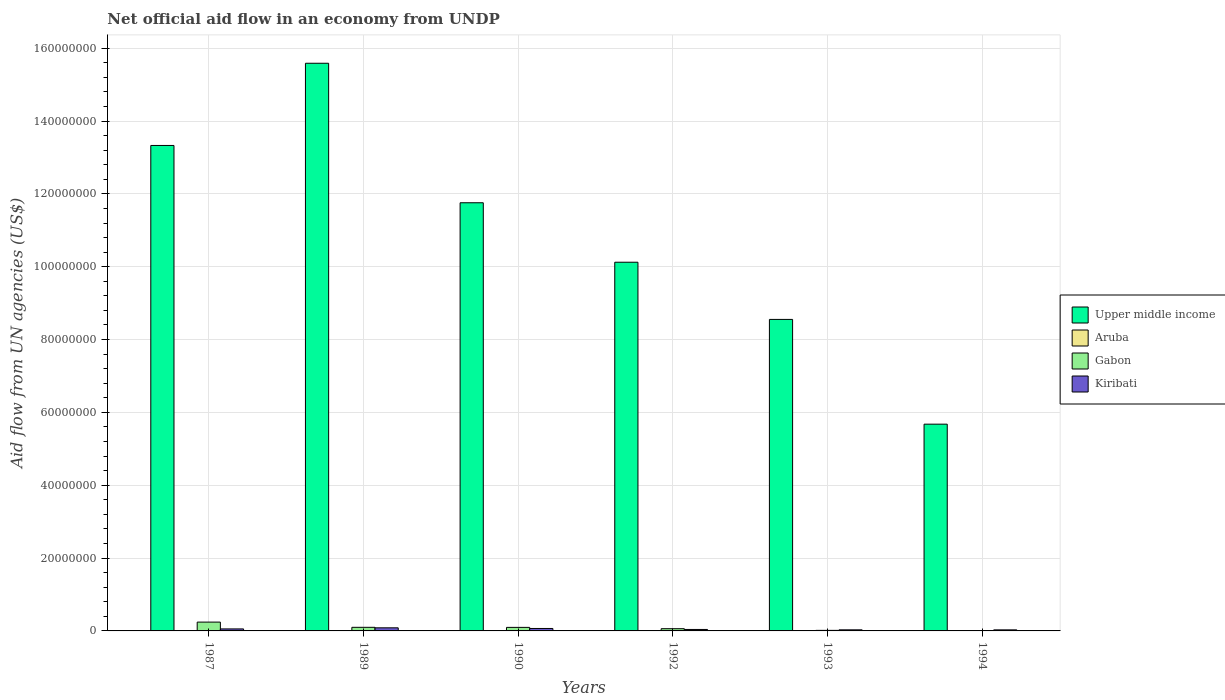How many different coloured bars are there?
Your response must be concise. 4. Are the number of bars per tick equal to the number of legend labels?
Offer a very short reply. No. Are the number of bars on each tick of the X-axis equal?
Give a very brief answer. No. How many bars are there on the 6th tick from the left?
Provide a short and direct response. 3. How many bars are there on the 3rd tick from the right?
Provide a succinct answer. 3. In how many cases, is the number of bars for a given year not equal to the number of legend labels?
Give a very brief answer. 2. Across all years, what is the maximum net official aid flow in Upper middle income?
Make the answer very short. 1.56e+08. In which year was the net official aid flow in Gabon maximum?
Ensure brevity in your answer.  1987. What is the difference between the net official aid flow in Upper middle income in 1989 and that in 1994?
Ensure brevity in your answer.  9.91e+07. What is the difference between the net official aid flow in Kiribati in 1987 and the net official aid flow in Gabon in 1989?
Offer a terse response. -4.40e+05. What is the average net official aid flow in Kiribati per year?
Your response must be concise. 5.10e+05. In the year 1992, what is the difference between the net official aid flow in Kiribati and net official aid flow in Upper middle income?
Provide a succinct answer. -1.01e+08. What is the ratio of the net official aid flow in Kiribati in 1987 to that in 1989?
Offer a terse response. 0.65. Is the net official aid flow in Upper middle income in 1990 less than that in 1993?
Make the answer very short. No. What is the difference between the highest and the second highest net official aid flow in Gabon?
Ensure brevity in your answer.  1.43e+06. What is the difference between the highest and the lowest net official aid flow in Gabon?
Make the answer very short. 2.40e+06. In how many years, is the net official aid flow in Aruba greater than the average net official aid flow in Aruba taken over all years?
Give a very brief answer. 3. Is it the case that in every year, the sum of the net official aid flow in Gabon and net official aid flow in Kiribati is greater than the net official aid flow in Aruba?
Your answer should be compact. Yes. Are all the bars in the graph horizontal?
Your answer should be very brief. No. What is the difference between two consecutive major ticks on the Y-axis?
Your answer should be compact. 2.00e+07. Are the values on the major ticks of Y-axis written in scientific E-notation?
Ensure brevity in your answer.  No. Does the graph contain any zero values?
Provide a succinct answer. Yes. Where does the legend appear in the graph?
Keep it short and to the point. Center right. How many legend labels are there?
Ensure brevity in your answer.  4. How are the legend labels stacked?
Offer a terse response. Vertical. What is the title of the graph?
Make the answer very short. Net official aid flow in an economy from UNDP. What is the label or title of the X-axis?
Give a very brief answer. Years. What is the label or title of the Y-axis?
Ensure brevity in your answer.  Aid flow from UN agencies (US$). What is the Aid flow from UN agencies (US$) of Upper middle income in 1987?
Give a very brief answer. 1.33e+08. What is the Aid flow from UN agencies (US$) in Aruba in 1987?
Make the answer very short. 8.00e+04. What is the Aid flow from UN agencies (US$) in Gabon in 1987?
Provide a succinct answer. 2.42e+06. What is the Aid flow from UN agencies (US$) of Upper middle income in 1989?
Provide a succinct answer. 1.56e+08. What is the Aid flow from UN agencies (US$) in Aruba in 1989?
Keep it short and to the point. 8.00e+04. What is the Aid flow from UN agencies (US$) of Gabon in 1989?
Keep it short and to the point. 9.90e+05. What is the Aid flow from UN agencies (US$) in Kiribati in 1989?
Your response must be concise. 8.50e+05. What is the Aid flow from UN agencies (US$) of Upper middle income in 1990?
Ensure brevity in your answer.  1.18e+08. What is the Aid flow from UN agencies (US$) of Gabon in 1990?
Offer a terse response. 9.70e+05. What is the Aid flow from UN agencies (US$) of Kiribati in 1990?
Keep it short and to the point. 6.70e+05. What is the Aid flow from UN agencies (US$) in Upper middle income in 1992?
Your response must be concise. 1.01e+08. What is the Aid flow from UN agencies (US$) in Gabon in 1992?
Make the answer very short. 6.10e+05. What is the Aid flow from UN agencies (US$) of Upper middle income in 1993?
Provide a succinct answer. 8.55e+07. What is the Aid flow from UN agencies (US$) in Aruba in 1993?
Your answer should be compact. 1.10e+05. What is the Aid flow from UN agencies (US$) in Upper middle income in 1994?
Give a very brief answer. 5.68e+07. What is the Aid flow from UN agencies (US$) of Aruba in 1994?
Offer a terse response. 0. Across all years, what is the maximum Aid flow from UN agencies (US$) in Upper middle income?
Your answer should be compact. 1.56e+08. Across all years, what is the maximum Aid flow from UN agencies (US$) of Gabon?
Ensure brevity in your answer.  2.42e+06. Across all years, what is the maximum Aid flow from UN agencies (US$) in Kiribati?
Your answer should be very brief. 8.50e+05. Across all years, what is the minimum Aid flow from UN agencies (US$) in Upper middle income?
Offer a terse response. 5.68e+07. What is the total Aid flow from UN agencies (US$) of Upper middle income in the graph?
Offer a terse response. 6.50e+08. What is the total Aid flow from UN agencies (US$) in Aruba in the graph?
Provide a short and direct response. 3.20e+05. What is the total Aid flow from UN agencies (US$) in Gabon in the graph?
Your answer should be compact. 5.16e+06. What is the total Aid flow from UN agencies (US$) in Kiribati in the graph?
Offer a very short reply. 3.06e+06. What is the difference between the Aid flow from UN agencies (US$) of Upper middle income in 1987 and that in 1989?
Your answer should be very brief. -2.26e+07. What is the difference between the Aid flow from UN agencies (US$) of Gabon in 1987 and that in 1989?
Offer a very short reply. 1.43e+06. What is the difference between the Aid flow from UN agencies (US$) of Upper middle income in 1987 and that in 1990?
Ensure brevity in your answer.  1.57e+07. What is the difference between the Aid flow from UN agencies (US$) of Aruba in 1987 and that in 1990?
Offer a very short reply. 3.00e+04. What is the difference between the Aid flow from UN agencies (US$) of Gabon in 1987 and that in 1990?
Provide a short and direct response. 1.45e+06. What is the difference between the Aid flow from UN agencies (US$) of Kiribati in 1987 and that in 1990?
Make the answer very short. -1.20e+05. What is the difference between the Aid flow from UN agencies (US$) of Upper middle income in 1987 and that in 1992?
Offer a terse response. 3.21e+07. What is the difference between the Aid flow from UN agencies (US$) in Gabon in 1987 and that in 1992?
Offer a terse response. 1.81e+06. What is the difference between the Aid flow from UN agencies (US$) in Kiribati in 1987 and that in 1992?
Your answer should be compact. 1.50e+05. What is the difference between the Aid flow from UN agencies (US$) in Upper middle income in 1987 and that in 1993?
Ensure brevity in your answer.  4.78e+07. What is the difference between the Aid flow from UN agencies (US$) in Gabon in 1987 and that in 1993?
Provide a succinct answer. 2.27e+06. What is the difference between the Aid flow from UN agencies (US$) in Kiribati in 1987 and that in 1993?
Provide a succinct answer. 2.50e+05. What is the difference between the Aid flow from UN agencies (US$) in Upper middle income in 1987 and that in 1994?
Your answer should be very brief. 7.65e+07. What is the difference between the Aid flow from UN agencies (US$) in Gabon in 1987 and that in 1994?
Offer a terse response. 2.40e+06. What is the difference between the Aid flow from UN agencies (US$) in Upper middle income in 1989 and that in 1990?
Your response must be concise. 3.83e+07. What is the difference between the Aid flow from UN agencies (US$) of Kiribati in 1989 and that in 1990?
Make the answer very short. 1.80e+05. What is the difference between the Aid flow from UN agencies (US$) in Upper middle income in 1989 and that in 1992?
Provide a succinct answer. 5.46e+07. What is the difference between the Aid flow from UN agencies (US$) of Upper middle income in 1989 and that in 1993?
Offer a terse response. 7.03e+07. What is the difference between the Aid flow from UN agencies (US$) of Aruba in 1989 and that in 1993?
Offer a terse response. -3.00e+04. What is the difference between the Aid flow from UN agencies (US$) of Gabon in 1989 and that in 1993?
Provide a short and direct response. 8.40e+05. What is the difference between the Aid flow from UN agencies (US$) in Upper middle income in 1989 and that in 1994?
Offer a very short reply. 9.91e+07. What is the difference between the Aid flow from UN agencies (US$) in Gabon in 1989 and that in 1994?
Keep it short and to the point. 9.70e+05. What is the difference between the Aid flow from UN agencies (US$) of Kiribati in 1989 and that in 1994?
Give a very brief answer. 5.60e+05. What is the difference between the Aid flow from UN agencies (US$) of Upper middle income in 1990 and that in 1992?
Provide a succinct answer. 1.63e+07. What is the difference between the Aid flow from UN agencies (US$) of Gabon in 1990 and that in 1992?
Keep it short and to the point. 3.60e+05. What is the difference between the Aid flow from UN agencies (US$) of Upper middle income in 1990 and that in 1993?
Offer a very short reply. 3.20e+07. What is the difference between the Aid flow from UN agencies (US$) of Aruba in 1990 and that in 1993?
Make the answer very short. -6.00e+04. What is the difference between the Aid flow from UN agencies (US$) of Gabon in 1990 and that in 1993?
Offer a terse response. 8.20e+05. What is the difference between the Aid flow from UN agencies (US$) in Upper middle income in 1990 and that in 1994?
Keep it short and to the point. 6.08e+07. What is the difference between the Aid flow from UN agencies (US$) of Gabon in 1990 and that in 1994?
Ensure brevity in your answer.  9.50e+05. What is the difference between the Aid flow from UN agencies (US$) in Kiribati in 1990 and that in 1994?
Offer a terse response. 3.80e+05. What is the difference between the Aid flow from UN agencies (US$) in Upper middle income in 1992 and that in 1993?
Provide a short and direct response. 1.57e+07. What is the difference between the Aid flow from UN agencies (US$) in Gabon in 1992 and that in 1993?
Offer a very short reply. 4.60e+05. What is the difference between the Aid flow from UN agencies (US$) in Kiribati in 1992 and that in 1993?
Provide a short and direct response. 1.00e+05. What is the difference between the Aid flow from UN agencies (US$) of Upper middle income in 1992 and that in 1994?
Your response must be concise. 4.45e+07. What is the difference between the Aid flow from UN agencies (US$) in Gabon in 1992 and that in 1994?
Make the answer very short. 5.90e+05. What is the difference between the Aid flow from UN agencies (US$) in Kiribati in 1992 and that in 1994?
Provide a short and direct response. 1.10e+05. What is the difference between the Aid flow from UN agencies (US$) of Upper middle income in 1993 and that in 1994?
Your answer should be compact. 2.88e+07. What is the difference between the Aid flow from UN agencies (US$) of Gabon in 1993 and that in 1994?
Give a very brief answer. 1.30e+05. What is the difference between the Aid flow from UN agencies (US$) of Upper middle income in 1987 and the Aid flow from UN agencies (US$) of Aruba in 1989?
Offer a very short reply. 1.33e+08. What is the difference between the Aid flow from UN agencies (US$) of Upper middle income in 1987 and the Aid flow from UN agencies (US$) of Gabon in 1989?
Give a very brief answer. 1.32e+08. What is the difference between the Aid flow from UN agencies (US$) of Upper middle income in 1987 and the Aid flow from UN agencies (US$) of Kiribati in 1989?
Offer a very short reply. 1.32e+08. What is the difference between the Aid flow from UN agencies (US$) of Aruba in 1987 and the Aid flow from UN agencies (US$) of Gabon in 1989?
Offer a terse response. -9.10e+05. What is the difference between the Aid flow from UN agencies (US$) of Aruba in 1987 and the Aid flow from UN agencies (US$) of Kiribati in 1989?
Make the answer very short. -7.70e+05. What is the difference between the Aid flow from UN agencies (US$) in Gabon in 1987 and the Aid flow from UN agencies (US$) in Kiribati in 1989?
Offer a very short reply. 1.57e+06. What is the difference between the Aid flow from UN agencies (US$) in Upper middle income in 1987 and the Aid flow from UN agencies (US$) in Aruba in 1990?
Make the answer very short. 1.33e+08. What is the difference between the Aid flow from UN agencies (US$) of Upper middle income in 1987 and the Aid flow from UN agencies (US$) of Gabon in 1990?
Provide a succinct answer. 1.32e+08. What is the difference between the Aid flow from UN agencies (US$) in Upper middle income in 1987 and the Aid flow from UN agencies (US$) in Kiribati in 1990?
Your answer should be very brief. 1.33e+08. What is the difference between the Aid flow from UN agencies (US$) in Aruba in 1987 and the Aid flow from UN agencies (US$) in Gabon in 1990?
Give a very brief answer. -8.90e+05. What is the difference between the Aid flow from UN agencies (US$) in Aruba in 1987 and the Aid flow from UN agencies (US$) in Kiribati in 1990?
Offer a very short reply. -5.90e+05. What is the difference between the Aid flow from UN agencies (US$) of Gabon in 1987 and the Aid flow from UN agencies (US$) of Kiribati in 1990?
Offer a very short reply. 1.75e+06. What is the difference between the Aid flow from UN agencies (US$) of Upper middle income in 1987 and the Aid flow from UN agencies (US$) of Gabon in 1992?
Make the answer very short. 1.33e+08. What is the difference between the Aid flow from UN agencies (US$) in Upper middle income in 1987 and the Aid flow from UN agencies (US$) in Kiribati in 1992?
Ensure brevity in your answer.  1.33e+08. What is the difference between the Aid flow from UN agencies (US$) of Aruba in 1987 and the Aid flow from UN agencies (US$) of Gabon in 1992?
Your answer should be very brief. -5.30e+05. What is the difference between the Aid flow from UN agencies (US$) of Aruba in 1987 and the Aid flow from UN agencies (US$) of Kiribati in 1992?
Your response must be concise. -3.20e+05. What is the difference between the Aid flow from UN agencies (US$) of Gabon in 1987 and the Aid flow from UN agencies (US$) of Kiribati in 1992?
Your answer should be compact. 2.02e+06. What is the difference between the Aid flow from UN agencies (US$) in Upper middle income in 1987 and the Aid flow from UN agencies (US$) in Aruba in 1993?
Your answer should be compact. 1.33e+08. What is the difference between the Aid flow from UN agencies (US$) of Upper middle income in 1987 and the Aid flow from UN agencies (US$) of Gabon in 1993?
Your answer should be very brief. 1.33e+08. What is the difference between the Aid flow from UN agencies (US$) in Upper middle income in 1987 and the Aid flow from UN agencies (US$) in Kiribati in 1993?
Your answer should be compact. 1.33e+08. What is the difference between the Aid flow from UN agencies (US$) in Aruba in 1987 and the Aid flow from UN agencies (US$) in Gabon in 1993?
Offer a very short reply. -7.00e+04. What is the difference between the Aid flow from UN agencies (US$) of Gabon in 1987 and the Aid flow from UN agencies (US$) of Kiribati in 1993?
Ensure brevity in your answer.  2.12e+06. What is the difference between the Aid flow from UN agencies (US$) of Upper middle income in 1987 and the Aid flow from UN agencies (US$) of Gabon in 1994?
Offer a terse response. 1.33e+08. What is the difference between the Aid flow from UN agencies (US$) of Upper middle income in 1987 and the Aid flow from UN agencies (US$) of Kiribati in 1994?
Keep it short and to the point. 1.33e+08. What is the difference between the Aid flow from UN agencies (US$) in Aruba in 1987 and the Aid flow from UN agencies (US$) in Gabon in 1994?
Offer a terse response. 6.00e+04. What is the difference between the Aid flow from UN agencies (US$) in Aruba in 1987 and the Aid flow from UN agencies (US$) in Kiribati in 1994?
Provide a succinct answer. -2.10e+05. What is the difference between the Aid flow from UN agencies (US$) in Gabon in 1987 and the Aid flow from UN agencies (US$) in Kiribati in 1994?
Your answer should be compact. 2.13e+06. What is the difference between the Aid flow from UN agencies (US$) of Upper middle income in 1989 and the Aid flow from UN agencies (US$) of Aruba in 1990?
Ensure brevity in your answer.  1.56e+08. What is the difference between the Aid flow from UN agencies (US$) of Upper middle income in 1989 and the Aid flow from UN agencies (US$) of Gabon in 1990?
Make the answer very short. 1.55e+08. What is the difference between the Aid flow from UN agencies (US$) in Upper middle income in 1989 and the Aid flow from UN agencies (US$) in Kiribati in 1990?
Provide a short and direct response. 1.55e+08. What is the difference between the Aid flow from UN agencies (US$) in Aruba in 1989 and the Aid flow from UN agencies (US$) in Gabon in 1990?
Offer a very short reply. -8.90e+05. What is the difference between the Aid flow from UN agencies (US$) in Aruba in 1989 and the Aid flow from UN agencies (US$) in Kiribati in 1990?
Give a very brief answer. -5.90e+05. What is the difference between the Aid flow from UN agencies (US$) of Gabon in 1989 and the Aid flow from UN agencies (US$) of Kiribati in 1990?
Make the answer very short. 3.20e+05. What is the difference between the Aid flow from UN agencies (US$) in Upper middle income in 1989 and the Aid flow from UN agencies (US$) in Gabon in 1992?
Provide a succinct answer. 1.55e+08. What is the difference between the Aid flow from UN agencies (US$) of Upper middle income in 1989 and the Aid flow from UN agencies (US$) of Kiribati in 1992?
Give a very brief answer. 1.55e+08. What is the difference between the Aid flow from UN agencies (US$) of Aruba in 1989 and the Aid flow from UN agencies (US$) of Gabon in 1992?
Give a very brief answer. -5.30e+05. What is the difference between the Aid flow from UN agencies (US$) of Aruba in 1989 and the Aid flow from UN agencies (US$) of Kiribati in 1992?
Provide a succinct answer. -3.20e+05. What is the difference between the Aid flow from UN agencies (US$) of Gabon in 1989 and the Aid flow from UN agencies (US$) of Kiribati in 1992?
Your answer should be very brief. 5.90e+05. What is the difference between the Aid flow from UN agencies (US$) of Upper middle income in 1989 and the Aid flow from UN agencies (US$) of Aruba in 1993?
Provide a succinct answer. 1.56e+08. What is the difference between the Aid flow from UN agencies (US$) in Upper middle income in 1989 and the Aid flow from UN agencies (US$) in Gabon in 1993?
Offer a terse response. 1.56e+08. What is the difference between the Aid flow from UN agencies (US$) of Upper middle income in 1989 and the Aid flow from UN agencies (US$) of Kiribati in 1993?
Provide a succinct answer. 1.56e+08. What is the difference between the Aid flow from UN agencies (US$) of Aruba in 1989 and the Aid flow from UN agencies (US$) of Kiribati in 1993?
Offer a terse response. -2.20e+05. What is the difference between the Aid flow from UN agencies (US$) of Gabon in 1989 and the Aid flow from UN agencies (US$) of Kiribati in 1993?
Provide a short and direct response. 6.90e+05. What is the difference between the Aid flow from UN agencies (US$) of Upper middle income in 1989 and the Aid flow from UN agencies (US$) of Gabon in 1994?
Provide a short and direct response. 1.56e+08. What is the difference between the Aid flow from UN agencies (US$) in Upper middle income in 1989 and the Aid flow from UN agencies (US$) in Kiribati in 1994?
Keep it short and to the point. 1.56e+08. What is the difference between the Aid flow from UN agencies (US$) of Aruba in 1989 and the Aid flow from UN agencies (US$) of Gabon in 1994?
Your response must be concise. 6.00e+04. What is the difference between the Aid flow from UN agencies (US$) of Aruba in 1989 and the Aid flow from UN agencies (US$) of Kiribati in 1994?
Keep it short and to the point. -2.10e+05. What is the difference between the Aid flow from UN agencies (US$) of Upper middle income in 1990 and the Aid flow from UN agencies (US$) of Gabon in 1992?
Your answer should be very brief. 1.17e+08. What is the difference between the Aid flow from UN agencies (US$) of Upper middle income in 1990 and the Aid flow from UN agencies (US$) of Kiribati in 1992?
Your answer should be compact. 1.17e+08. What is the difference between the Aid flow from UN agencies (US$) in Aruba in 1990 and the Aid flow from UN agencies (US$) in Gabon in 1992?
Give a very brief answer. -5.60e+05. What is the difference between the Aid flow from UN agencies (US$) in Aruba in 1990 and the Aid flow from UN agencies (US$) in Kiribati in 1992?
Offer a very short reply. -3.50e+05. What is the difference between the Aid flow from UN agencies (US$) in Gabon in 1990 and the Aid flow from UN agencies (US$) in Kiribati in 1992?
Keep it short and to the point. 5.70e+05. What is the difference between the Aid flow from UN agencies (US$) of Upper middle income in 1990 and the Aid flow from UN agencies (US$) of Aruba in 1993?
Keep it short and to the point. 1.17e+08. What is the difference between the Aid flow from UN agencies (US$) in Upper middle income in 1990 and the Aid flow from UN agencies (US$) in Gabon in 1993?
Provide a succinct answer. 1.17e+08. What is the difference between the Aid flow from UN agencies (US$) of Upper middle income in 1990 and the Aid flow from UN agencies (US$) of Kiribati in 1993?
Ensure brevity in your answer.  1.17e+08. What is the difference between the Aid flow from UN agencies (US$) in Aruba in 1990 and the Aid flow from UN agencies (US$) in Gabon in 1993?
Offer a terse response. -1.00e+05. What is the difference between the Aid flow from UN agencies (US$) in Aruba in 1990 and the Aid flow from UN agencies (US$) in Kiribati in 1993?
Make the answer very short. -2.50e+05. What is the difference between the Aid flow from UN agencies (US$) of Gabon in 1990 and the Aid flow from UN agencies (US$) of Kiribati in 1993?
Make the answer very short. 6.70e+05. What is the difference between the Aid flow from UN agencies (US$) of Upper middle income in 1990 and the Aid flow from UN agencies (US$) of Gabon in 1994?
Keep it short and to the point. 1.18e+08. What is the difference between the Aid flow from UN agencies (US$) of Upper middle income in 1990 and the Aid flow from UN agencies (US$) of Kiribati in 1994?
Your answer should be very brief. 1.17e+08. What is the difference between the Aid flow from UN agencies (US$) of Aruba in 1990 and the Aid flow from UN agencies (US$) of Gabon in 1994?
Offer a very short reply. 3.00e+04. What is the difference between the Aid flow from UN agencies (US$) in Gabon in 1990 and the Aid flow from UN agencies (US$) in Kiribati in 1994?
Give a very brief answer. 6.80e+05. What is the difference between the Aid flow from UN agencies (US$) in Upper middle income in 1992 and the Aid flow from UN agencies (US$) in Aruba in 1993?
Give a very brief answer. 1.01e+08. What is the difference between the Aid flow from UN agencies (US$) in Upper middle income in 1992 and the Aid flow from UN agencies (US$) in Gabon in 1993?
Make the answer very short. 1.01e+08. What is the difference between the Aid flow from UN agencies (US$) in Upper middle income in 1992 and the Aid flow from UN agencies (US$) in Kiribati in 1993?
Offer a terse response. 1.01e+08. What is the difference between the Aid flow from UN agencies (US$) in Upper middle income in 1992 and the Aid flow from UN agencies (US$) in Gabon in 1994?
Your answer should be very brief. 1.01e+08. What is the difference between the Aid flow from UN agencies (US$) in Upper middle income in 1992 and the Aid flow from UN agencies (US$) in Kiribati in 1994?
Make the answer very short. 1.01e+08. What is the difference between the Aid flow from UN agencies (US$) in Gabon in 1992 and the Aid flow from UN agencies (US$) in Kiribati in 1994?
Provide a succinct answer. 3.20e+05. What is the difference between the Aid flow from UN agencies (US$) in Upper middle income in 1993 and the Aid flow from UN agencies (US$) in Gabon in 1994?
Your answer should be very brief. 8.55e+07. What is the difference between the Aid flow from UN agencies (US$) in Upper middle income in 1993 and the Aid flow from UN agencies (US$) in Kiribati in 1994?
Offer a very short reply. 8.52e+07. What is the difference between the Aid flow from UN agencies (US$) in Aruba in 1993 and the Aid flow from UN agencies (US$) in Gabon in 1994?
Provide a short and direct response. 9.00e+04. What is the difference between the Aid flow from UN agencies (US$) of Aruba in 1993 and the Aid flow from UN agencies (US$) of Kiribati in 1994?
Give a very brief answer. -1.80e+05. What is the average Aid flow from UN agencies (US$) in Upper middle income per year?
Make the answer very short. 1.08e+08. What is the average Aid flow from UN agencies (US$) in Aruba per year?
Give a very brief answer. 5.33e+04. What is the average Aid flow from UN agencies (US$) in Gabon per year?
Your answer should be very brief. 8.60e+05. What is the average Aid flow from UN agencies (US$) of Kiribati per year?
Ensure brevity in your answer.  5.10e+05. In the year 1987, what is the difference between the Aid flow from UN agencies (US$) in Upper middle income and Aid flow from UN agencies (US$) in Aruba?
Make the answer very short. 1.33e+08. In the year 1987, what is the difference between the Aid flow from UN agencies (US$) in Upper middle income and Aid flow from UN agencies (US$) in Gabon?
Ensure brevity in your answer.  1.31e+08. In the year 1987, what is the difference between the Aid flow from UN agencies (US$) in Upper middle income and Aid flow from UN agencies (US$) in Kiribati?
Offer a terse response. 1.33e+08. In the year 1987, what is the difference between the Aid flow from UN agencies (US$) in Aruba and Aid flow from UN agencies (US$) in Gabon?
Give a very brief answer. -2.34e+06. In the year 1987, what is the difference between the Aid flow from UN agencies (US$) of Aruba and Aid flow from UN agencies (US$) of Kiribati?
Ensure brevity in your answer.  -4.70e+05. In the year 1987, what is the difference between the Aid flow from UN agencies (US$) in Gabon and Aid flow from UN agencies (US$) in Kiribati?
Make the answer very short. 1.87e+06. In the year 1989, what is the difference between the Aid flow from UN agencies (US$) of Upper middle income and Aid flow from UN agencies (US$) of Aruba?
Provide a succinct answer. 1.56e+08. In the year 1989, what is the difference between the Aid flow from UN agencies (US$) in Upper middle income and Aid flow from UN agencies (US$) in Gabon?
Ensure brevity in your answer.  1.55e+08. In the year 1989, what is the difference between the Aid flow from UN agencies (US$) of Upper middle income and Aid flow from UN agencies (US$) of Kiribati?
Your answer should be compact. 1.55e+08. In the year 1989, what is the difference between the Aid flow from UN agencies (US$) of Aruba and Aid flow from UN agencies (US$) of Gabon?
Give a very brief answer. -9.10e+05. In the year 1989, what is the difference between the Aid flow from UN agencies (US$) of Aruba and Aid flow from UN agencies (US$) of Kiribati?
Your answer should be very brief. -7.70e+05. In the year 1990, what is the difference between the Aid flow from UN agencies (US$) in Upper middle income and Aid flow from UN agencies (US$) in Aruba?
Your answer should be compact. 1.18e+08. In the year 1990, what is the difference between the Aid flow from UN agencies (US$) in Upper middle income and Aid flow from UN agencies (US$) in Gabon?
Offer a very short reply. 1.17e+08. In the year 1990, what is the difference between the Aid flow from UN agencies (US$) of Upper middle income and Aid flow from UN agencies (US$) of Kiribati?
Provide a succinct answer. 1.17e+08. In the year 1990, what is the difference between the Aid flow from UN agencies (US$) of Aruba and Aid flow from UN agencies (US$) of Gabon?
Your answer should be compact. -9.20e+05. In the year 1990, what is the difference between the Aid flow from UN agencies (US$) of Aruba and Aid flow from UN agencies (US$) of Kiribati?
Keep it short and to the point. -6.20e+05. In the year 1990, what is the difference between the Aid flow from UN agencies (US$) of Gabon and Aid flow from UN agencies (US$) of Kiribati?
Your response must be concise. 3.00e+05. In the year 1992, what is the difference between the Aid flow from UN agencies (US$) of Upper middle income and Aid flow from UN agencies (US$) of Gabon?
Your answer should be very brief. 1.01e+08. In the year 1992, what is the difference between the Aid flow from UN agencies (US$) in Upper middle income and Aid flow from UN agencies (US$) in Kiribati?
Provide a succinct answer. 1.01e+08. In the year 1992, what is the difference between the Aid flow from UN agencies (US$) of Gabon and Aid flow from UN agencies (US$) of Kiribati?
Ensure brevity in your answer.  2.10e+05. In the year 1993, what is the difference between the Aid flow from UN agencies (US$) of Upper middle income and Aid flow from UN agencies (US$) of Aruba?
Your response must be concise. 8.54e+07. In the year 1993, what is the difference between the Aid flow from UN agencies (US$) of Upper middle income and Aid flow from UN agencies (US$) of Gabon?
Make the answer very short. 8.54e+07. In the year 1993, what is the difference between the Aid flow from UN agencies (US$) in Upper middle income and Aid flow from UN agencies (US$) in Kiribati?
Make the answer very short. 8.52e+07. In the year 1993, what is the difference between the Aid flow from UN agencies (US$) in Aruba and Aid flow from UN agencies (US$) in Gabon?
Offer a terse response. -4.00e+04. In the year 1993, what is the difference between the Aid flow from UN agencies (US$) in Aruba and Aid flow from UN agencies (US$) in Kiribati?
Give a very brief answer. -1.90e+05. In the year 1993, what is the difference between the Aid flow from UN agencies (US$) in Gabon and Aid flow from UN agencies (US$) in Kiribati?
Your answer should be compact. -1.50e+05. In the year 1994, what is the difference between the Aid flow from UN agencies (US$) in Upper middle income and Aid flow from UN agencies (US$) in Gabon?
Ensure brevity in your answer.  5.68e+07. In the year 1994, what is the difference between the Aid flow from UN agencies (US$) of Upper middle income and Aid flow from UN agencies (US$) of Kiribati?
Provide a succinct answer. 5.65e+07. In the year 1994, what is the difference between the Aid flow from UN agencies (US$) in Gabon and Aid flow from UN agencies (US$) in Kiribati?
Your answer should be very brief. -2.70e+05. What is the ratio of the Aid flow from UN agencies (US$) in Upper middle income in 1987 to that in 1989?
Provide a succinct answer. 0.86. What is the ratio of the Aid flow from UN agencies (US$) of Gabon in 1987 to that in 1989?
Keep it short and to the point. 2.44. What is the ratio of the Aid flow from UN agencies (US$) in Kiribati in 1987 to that in 1989?
Keep it short and to the point. 0.65. What is the ratio of the Aid flow from UN agencies (US$) in Upper middle income in 1987 to that in 1990?
Provide a succinct answer. 1.13. What is the ratio of the Aid flow from UN agencies (US$) in Aruba in 1987 to that in 1990?
Keep it short and to the point. 1.6. What is the ratio of the Aid flow from UN agencies (US$) in Gabon in 1987 to that in 1990?
Make the answer very short. 2.49. What is the ratio of the Aid flow from UN agencies (US$) in Kiribati in 1987 to that in 1990?
Give a very brief answer. 0.82. What is the ratio of the Aid flow from UN agencies (US$) in Upper middle income in 1987 to that in 1992?
Give a very brief answer. 1.32. What is the ratio of the Aid flow from UN agencies (US$) in Gabon in 1987 to that in 1992?
Your answer should be very brief. 3.97. What is the ratio of the Aid flow from UN agencies (US$) of Kiribati in 1987 to that in 1992?
Ensure brevity in your answer.  1.38. What is the ratio of the Aid flow from UN agencies (US$) in Upper middle income in 1987 to that in 1993?
Offer a very short reply. 1.56. What is the ratio of the Aid flow from UN agencies (US$) of Aruba in 1987 to that in 1993?
Offer a terse response. 0.73. What is the ratio of the Aid flow from UN agencies (US$) of Gabon in 1987 to that in 1993?
Offer a terse response. 16.13. What is the ratio of the Aid flow from UN agencies (US$) of Kiribati in 1987 to that in 1993?
Offer a terse response. 1.83. What is the ratio of the Aid flow from UN agencies (US$) of Upper middle income in 1987 to that in 1994?
Give a very brief answer. 2.35. What is the ratio of the Aid flow from UN agencies (US$) of Gabon in 1987 to that in 1994?
Your answer should be very brief. 121. What is the ratio of the Aid flow from UN agencies (US$) in Kiribati in 1987 to that in 1994?
Your answer should be compact. 1.9. What is the ratio of the Aid flow from UN agencies (US$) in Upper middle income in 1989 to that in 1990?
Offer a terse response. 1.33. What is the ratio of the Aid flow from UN agencies (US$) in Gabon in 1989 to that in 1990?
Your response must be concise. 1.02. What is the ratio of the Aid flow from UN agencies (US$) of Kiribati in 1989 to that in 1990?
Your answer should be very brief. 1.27. What is the ratio of the Aid flow from UN agencies (US$) of Upper middle income in 1989 to that in 1992?
Ensure brevity in your answer.  1.54. What is the ratio of the Aid flow from UN agencies (US$) in Gabon in 1989 to that in 1992?
Offer a terse response. 1.62. What is the ratio of the Aid flow from UN agencies (US$) of Kiribati in 1989 to that in 1992?
Give a very brief answer. 2.12. What is the ratio of the Aid flow from UN agencies (US$) in Upper middle income in 1989 to that in 1993?
Provide a short and direct response. 1.82. What is the ratio of the Aid flow from UN agencies (US$) in Aruba in 1989 to that in 1993?
Give a very brief answer. 0.73. What is the ratio of the Aid flow from UN agencies (US$) of Kiribati in 1989 to that in 1993?
Keep it short and to the point. 2.83. What is the ratio of the Aid flow from UN agencies (US$) of Upper middle income in 1989 to that in 1994?
Your answer should be compact. 2.75. What is the ratio of the Aid flow from UN agencies (US$) in Gabon in 1989 to that in 1994?
Provide a succinct answer. 49.5. What is the ratio of the Aid flow from UN agencies (US$) of Kiribati in 1989 to that in 1994?
Ensure brevity in your answer.  2.93. What is the ratio of the Aid flow from UN agencies (US$) of Upper middle income in 1990 to that in 1992?
Provide a succinct answer. 1.16. What is the ratio of the Aid flow from UN agencies (US$) of Gabon in 1990 to that in 1992?
Your response must be concise. 1.59. What is the ratio of the Aid flow from UN agencies (US$) of Kiribati in 1990 to that in 1992?
Keep it short and to the point. 1.68. What is the ratio of the Aid flow from UN agencies (US$) of Upper middle income in 1990 to that in 1993?
Your answer should be very brief. 1.37. What is the ratio of the Aid flow from UN agencies (US$) of Aruba in 1990 to that in 1993?
Give a very brief answer. 0.45. What is the ratio of the Aid flow from UN agencies (US$) in Gabon in 1990 to that in 1993?
Ensure brevity in your answer.  6.47. What is the ratio of the Aid flow from UN agencies (US$) of Kiribati in 1990 to that in 1993?
Ensure brevity in your answer.  2.23. What is the ratio of the Aid flow from UN agencies (US$) of Upper middle income in 1990 to that in 1994?
Your response must be concise. 2.07. What is the ratio of the Aid flow from UN agencies (US$) of Gabon in 1990 to that in 1994?
Your answer should be very brief. 48.5. What is the ratio of the Aid flow from UN agencies (US$) of Kiribati in 1990 to that in 1994?
Offer a terse response. 2.31. What is the ratio of the Aid flow from UN agencies (US$) of Upper middle income in 1992 to that in 1993?
Provide a short and direct response. 1.18. What is the ratio of the Aid flow from UN agencies (US$) in Gabon in 1992 to that in 1993?
Your response must be concise. 4.07. What is the ratio of the Aid flow from UN agencies (US$) in Kiribati in 1992 to that in 1993?
Make the answer very short. 1.33. What is the ratio of the Aid flow from UN agencies (US$) of Upper middle income in 1992 to that in 1994?
Your response must be concise. 1.78. What is the ratio of the Aid flow from UN agencies (US$) in Gabon in 1992 to that in 1994?
Keep it short and to the point. 30.5. What is the ratio of the Aid flow from UN agencies (US$) in Kiribati in 1992 to that in 1994?
Offer a very short reply. 1.38. What is the ratio of the Aid flow from UN agencies (US$) in Upper middle income in 1993 to that in 1994?
Keep it short and to the point. 1.51. What is the ratio of the Aid flow from UN agencies (US$) in Kiribati in 1993 to that in 1994?
Provide a succinct answer. 1.03. What is the difference between the highest and the second highest Aid flow from UN agencies (US$) in Upper middle income?
Your answer should be very brief. 2.26e+07. What is the difference between the highest and the second highest Aid flow from UN agencies (US$) of Gabon?
Make the answer very short. 1.43e+06. What is the difference between the highest and the second highest Aid flow from UN agencies (US$) of Kiribati?
Provide a short and direct response. 1.80e+05. What is the difference between the highest and the lowest Aid flow from UN agencies (US$) of Upper middle income?
Provide a succinct answer. 9.91e+07. What is the difference between the highest and the lowest Aid flow from UN agencies (US$) in Aruba?
Your response must be concise. 1.10e+05. What is the difference between the highest and the lowest Aid flow from UN agencies (US$) of Gabon?
Your response must be concise. 2.40e+06. What is the difference between the highest and the lowest Aid flow from UN agencies (US$) in Kiribati?
Make the answer very short. 5.60e+05. 